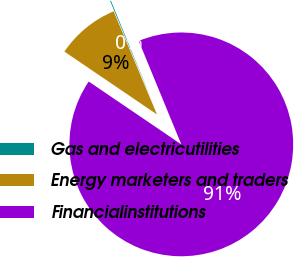Convert chart. <chart><loc_0><loc_0><loc_500><loc_500><pie_chart><fcel>Gas and electricutilities<fcel>Energy marketers and traders<fcel>Financialinstitutions<nl><fcel>0.12%<fcel>9.18%<fcel>90.71%<nl></chart> 